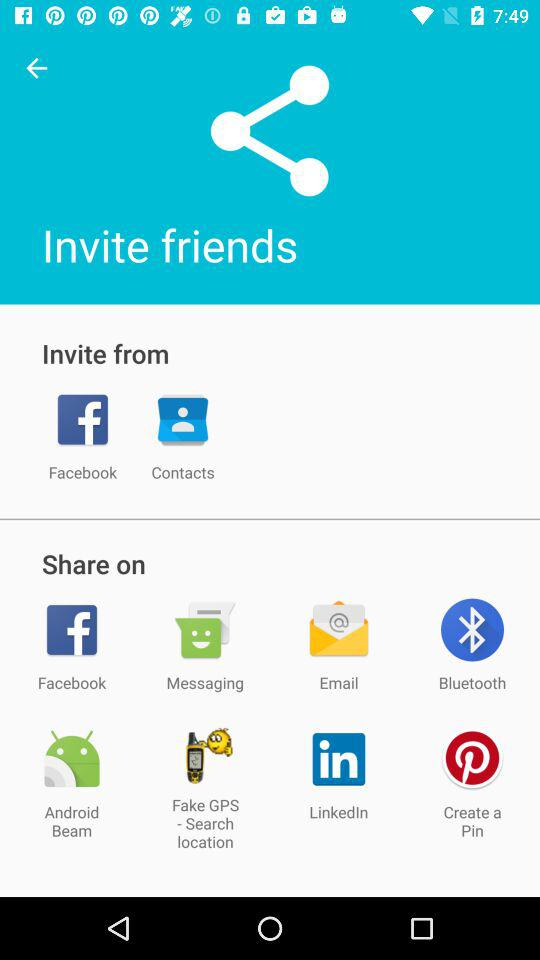What are the applications through which users can invite friends? The applications are "Facebook" and "Contacts". 